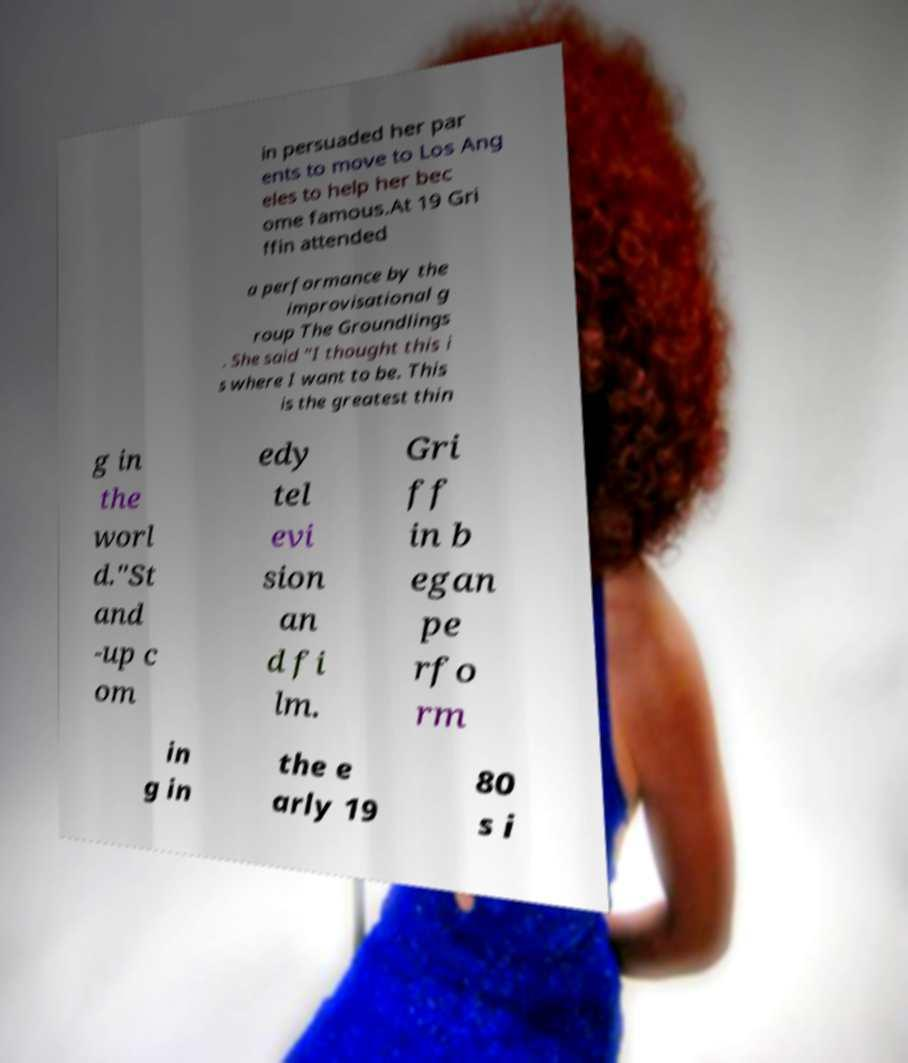Please read and relay the text visible in this image. What does it say? in persuaded her par ents to move to Los Ang eles to help her bec ome famous.At 19 Gri ffin attended a performance by the improvisational g roup The Groundlings . She said "I thought this i s where I want to be. This is the greatest thin g in the worl d."St and -up c om edy tel evi sion an d fi lm. Gri ff in b egan pe rfo rm in g in the e arly 19 80 s i 